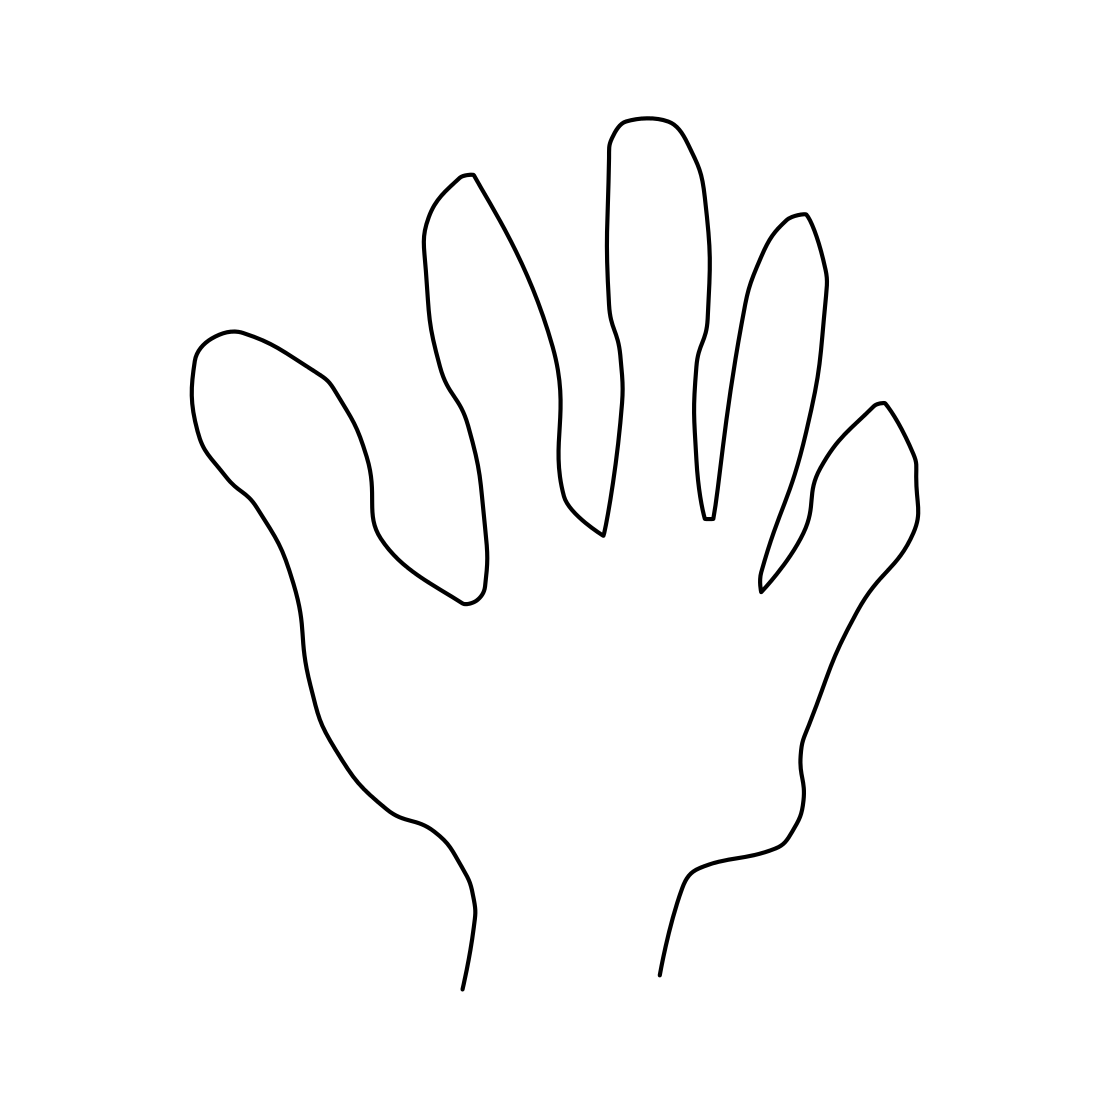Could this image be symbolizing something? Certainly, this simple line drawing of a hand could symbolize various concepts depending on the context. It might symbolize human interaction, creativity, or assistance. In some cultures, hand imagery can represent specific ideas like peace with a raised hand or five elements of nature due to the five fingers. 